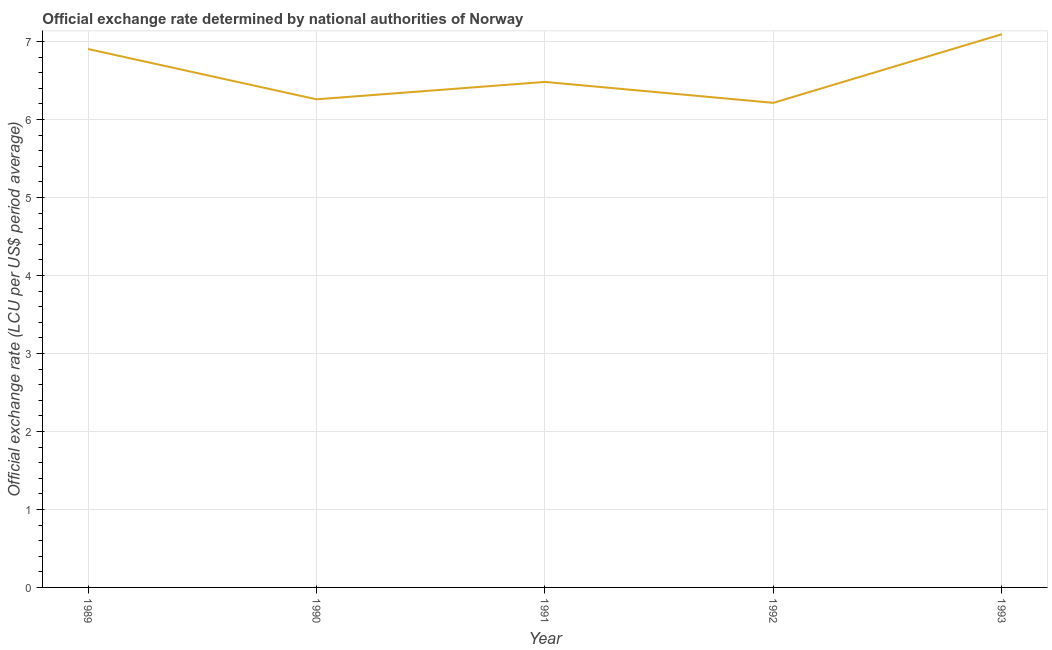What is the official exchange rate in 1992?
Your answer should be compact. 6.21. Across all years, what is the maximum official exchange rate?
Give a very brief answer. 7.09. Across all years, what is the minimum official exchange rate?
Ensure brevity in your answer.  6.21. What is the sum of the official exchange rate?
Offer a terse response. 32.96. What is the difference between the official exchange rate in 1992 and 1993?
Keep it short and to the point. -0.88. What is the average official exchange rate per year?
Offer a terse response. 6.59. What is the median official exchange rate?
Your answer should be compact. 6.48. What is the ratio of the official exchange rate in 1989 to that in 1991?
Ensure brevity in your answer.  1.07. Is the official exchange rate in 1992 less than that in 1993?
Your answer should be very brief. Yes. What is the difference between the highest and the second highest official exchange rate?
Your response must be concise. 0.19. What is the difference between the highest and the lowest official exchange rate?
Ensure brevity in your answer.  0.88. How many lines are there?
Your answer should be compact. 1. What is the difference between two consecutive major ticks on the Y-axis?
Offer a very short reply. 1. Does the graph contain any zero values?
Make the answer very short. No. What is the title of the graph?
Your response must be concise. Official exchange rate determined by national authorities of Norway. What is the label or title of the X-axis?
Offer a very short reply. Year. What is the label or title of the Y-axis?
Give a very brief answer. Official exchange rate (LCU per US$ period average). What is the Official exchange rate (LCU per US$ period average) in 1989?
Offer a terse response. 6.9. What is the Official exchange rate (LCU per US$ period average) in 1990?
Make the answer very short. 6.26. What is the Official exchange rate (LCU per US$ period average) in 1991?
Make the answer very short. 6.48. What is the Official exchange rate (LCU per US$ period average) in 1992?
Keep it short and to the point. 6.21. What is the Official exchange rate (LCU per US$ period average) in 1993?
Your response must be concise. 7.09. What is the difference between the Official exchange rate (LCU per US$ period average) in 1989 and 1990?
Your response must be concise. 0.64. What is the difference between the Official exchange rate (LCU per US$ period average) in 1989 and 1991?
Provide a short and direct response. 0.42. What is the difference between the Official exchange rate (LCU per US$ period average) in 1989 and 1992?
Provide a short and direct response. 0.69. What is the difference between the Official exchange rate (LCU per US$ period average) in 1989 and 1993?
Your answer should be very brief. -0.19. What is the difference between the Official exchange rate (LCU per US$ period average) in 1990 and 1991?
Provide a succinct answer. -0.22. What is the difference between the Official exchange rate (LCU per US$ period average) in 1990 and 1992?
Your answer should be very brief. 0.05. What is the difference between the Official exchange rate (LCU per US$ period average) in 1990 and 1993?
Ensure brevity in your answer.  -0.83. What is the difference between the Official exchange rate (LCU per US$ period average) in 1991 and 1992?
Give a very brief answer. 0.27. What is the difference between the Official exchange rate (LCU per US$ period average) in 1991 and 1993?
Your answer should be very brief. -0.61. What is the difference between the Official exchange rate (LCU per US$ period average) in 1992 and 1993?
Make the answer very short. -0.88. What is the ratio of the Official exchange rate (LCU per US$ period average) in 1989 to that in 1990?
Provide a succinct answer. 1.1. What is the ratio of the Official exchange rate (LCU per US$ period average) in 1989 to that in 1991?
Keep it short and to the point. 1.06. What is the ratio of the Official exchange rate (LCU per US$ period average) in 1989 to that in 1992?
Your response must be concise. 1.11. What is the ratio of the Official exchange rate (LCU per US$ period average) in 1989 to that in 1993?
Give a very brief answer. 0.97. What is the ratio of the Official exchange rate (LCU per US$ period average) in 1990 to that in 1991?
Give a very brief answer. 0.97. What is the ratio of the Official exchange rate (LCU per US$ period average) in 1990 to that in 1993?
Offer a terse response. 0.88. What is the ratio of the Official exchange rate (LCU per US$ period average) in 1991 to that in 1992?
Make the answer very short. 1.04. What is the ratio of the Official exchange rate (LCU per US$ period average) in 1991 to that in 1993?
Make the answer very short. 0.91. What is the ratio of the Official exchange rate (LCU per US$ period average) in 1992 to that in 1993?
Your answer should be compact. 0.88. 